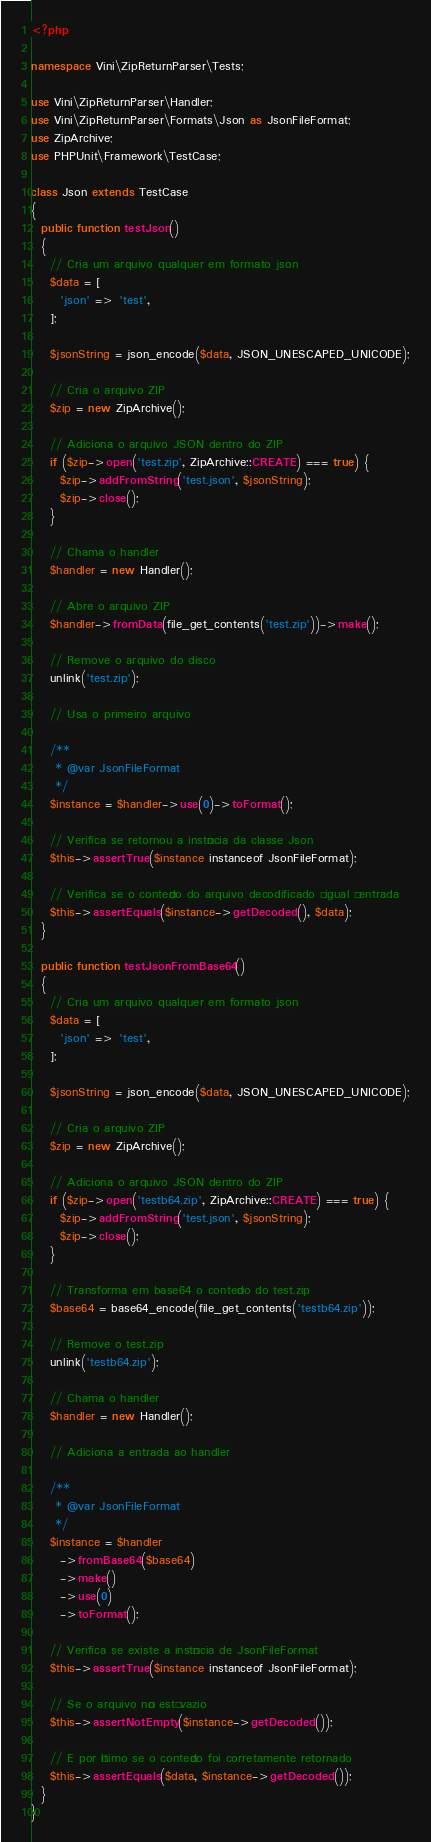<code> <loc_0><loc_0><loc_500><loc_500><_PHP_><?php

namespace Vini\ZipReturnParser\Tests;

use Vini\ZipReturnParser\Handler;
use Vini\ZipReturnParser\Formats\Json as JsonFileFormat;
use ZipArchive;
use PHPUnit\Framework\TestCase;

class Json extends TestCase
{
  public function testJson()
  {
    // Cria um arquivo qualquer em formato json
    $data = [
      'json' => 'test',
    ];

    $jsonString = json_encode($data, JSON_UNESCAPED_UNICODE);

    // Cria o arquivo ZIP
    $zip = new ZipArchive();

    // Adiciona o arquivo JSON dentro do ZIP
    if ($zip->open('test.zip', ZipArchive::CREATE) === true) {
      $zip->addFromString('test.json', $jsonString);
      $zip->close();
    }

    // Chama o handler
    $handler = new Handler();

    // Abre o arquivo ZIP
    $handler->fromData(file_get_contents('test.zip'))->make();

    // Remove o arquivo do disco
    unlink('test.zip');

    // Usa o primeiro arquivo

    /**
     * @var JsonFileFormat
     */
    $instance = $handler->use(0)->toFormat();

    // Verifica se retornou a instância da classe Json
    $this->assertTrue($instance instanceof JsonFileFormat);

    // Verifica se o conteúdo do arquivo decodificado é igual ã entrada
    $this->assertEquals($instance->getDecoded(), $data);
  }

  public function testJsonFromBase64()
  {
    // Cria um arquivo qualquer em formato json
    $data = [
      'json' => 'test',
    ];

    $jsonString = json_encode($data, JSON_UNESCAPED_UNICODE);

    // Cria o arquivo ZIP
    $zip = new ZipArchive();

    // Adiciona o arquivo JSON dentro do ZIP
    if ($zip->open('testb64.zip', ZipArchive::CREATE) === true) {
      $zip->addFromString('test.json', $jsonString);
      $zip->close();
    }

    // Transforma em base64 o conteúdo do test.zip
    $base64 = base64_encode(file_get_contents('testb64.zip'));

    // Remove o test.zip
    unlink('testb64.zip');

    // Chama o handler
    $handler = new Handler();

    // Adiciona a entrada ao handler

    /**
     * @var JsonFileFormat
     */
    $instance = $handler
      ->fromBase64($base64)
      ->make()
      ->use(0)
      ->toFormat();

    // Verifica se existe a instância de JsonFileFormat
    $this->assertTrue($instance instanceof JsonFileFormat);

    // Se o arquivo não está vazio
    $this->assertNotEmpty($instance->getDecoded());

    // E por último se o conteúdo foi corretamente retornado
    $this->assertEquals($data, $instance->getDecoded());
  }
}
</code> 